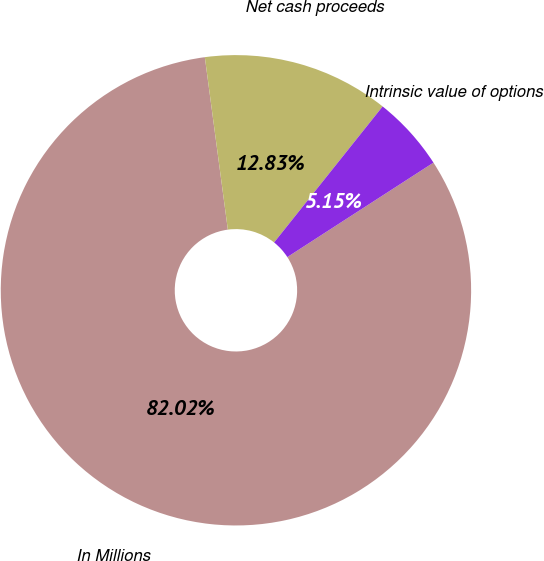Convert chart. <chart><loc_0><loc_0><loc_500><loc_500><pie_chart><fcel>In Millions<fcel>Net cash proceeds<fcel>Intrinsic value of options<nl><fcel>82.02%<fcel>12.83%<fcel>5.15%<nl></chart> 